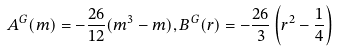<formula> <loc_0><loc_0><loc_500><loc_500>A ^ { G } ( m ) = - \frac { 2 6 } { 1 2 } ( m ^ { 3 } - m ) , B ^ { G } ( r ) = - \frac { 2 6 } { 3 } \left ( r ^ { 2 } - \frac { 1 } { 4 } \right )</formula> 